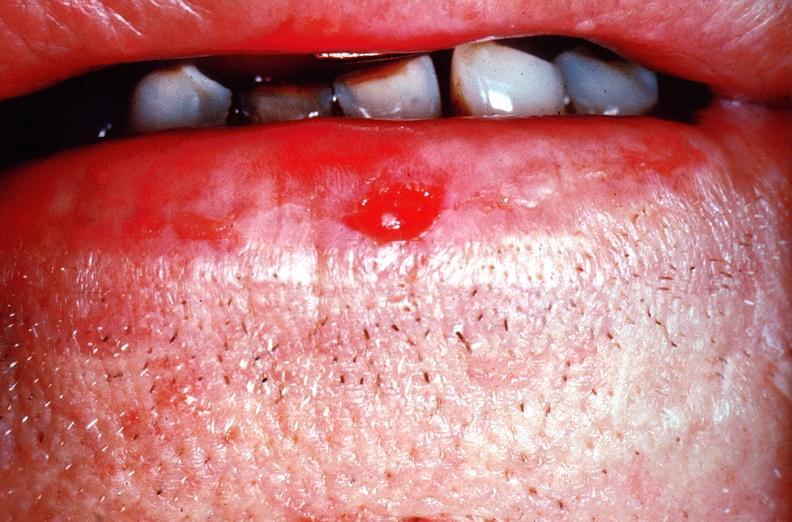does this image show squamous cell carcinoma of the lip?
Answer the question using a single word or phrase. Yes 